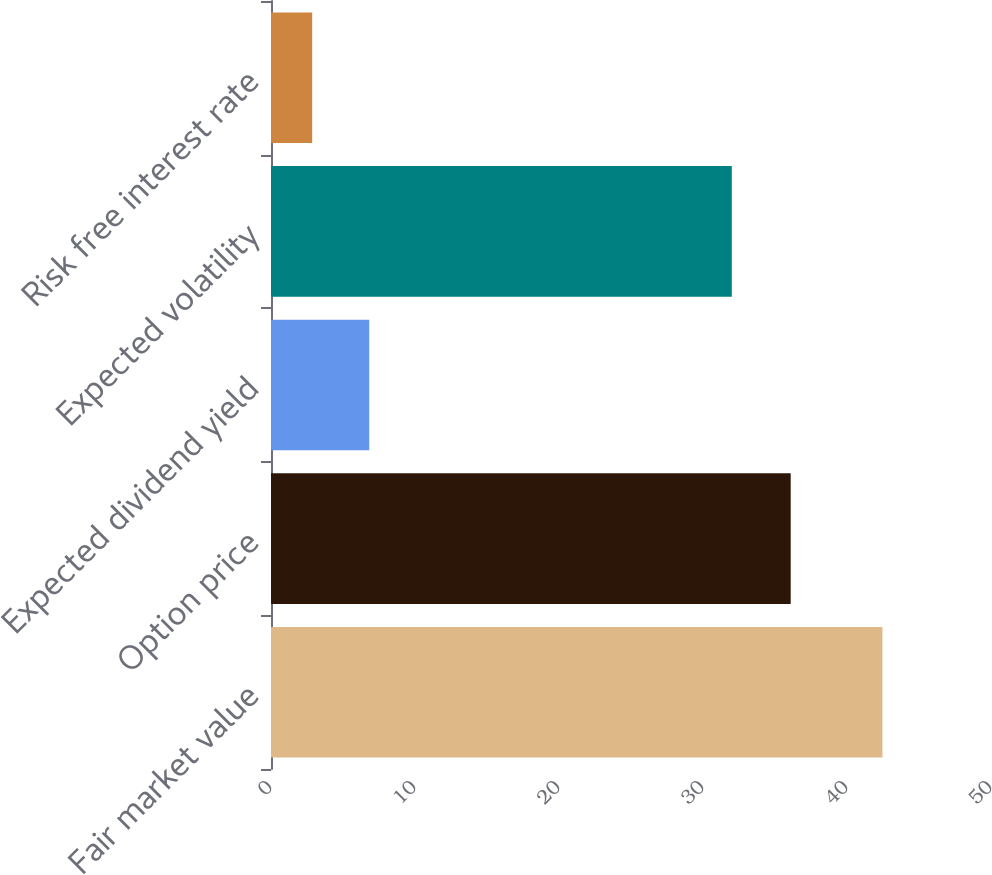Convert chart. <chart><loc_0><loc_0><loc_500><loc_500><bar_chart><fcel>Fair market value<fcel>Option price<fcel>Expected dividend yield<fcel>Expected volatility<fcel>Risk free interest rate<nl><fcel>42.46<fcel>36.09<fcel>6.82<fcel>32<fcel>2.86<nl></chart> 